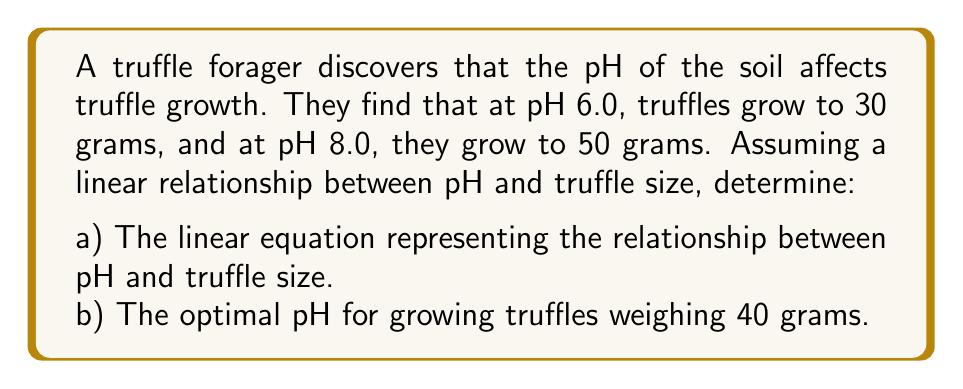Can you answer this question? Let's approach this step-by-step:

1) We're given two points: (6.0, 30) and (8.0, 50), where x represents pH and y represents truffle size in grams.

2) To find the linear equation, we'll use the point-slope form: $y - y_1 = m(x - x_1)$

3) First, calculate the slope (m):
   $$m = \frac{y_2 - y_1}{x_2 - x_1} = \frac{50 - 30}{8.0 - 6.0} = \frac{20}{2} = 10$$

4) Now we can use either point to create the equation. Let's use (6.0, 30):
   $y - 30 = 10(x - 6.0)$

5) Simplify:
   $y = 10x - 60 + 30$
   $y = 10x - 30$

6) This is our linear equation: $y = 10x - 30$, where y is truffle size in grams and x is pH.

7) To find the optimal pH for 40-gram truffles, we substitute y with 40:
   $40 = 10x - 30$

8) Solve for x:
   $70 = 10x$
   $x = 7$

Therefore, the optimal pH for growing 40-gram truffles is 7.0.
Answer: a) $y = 10x - 30$
b) pH 7.0 